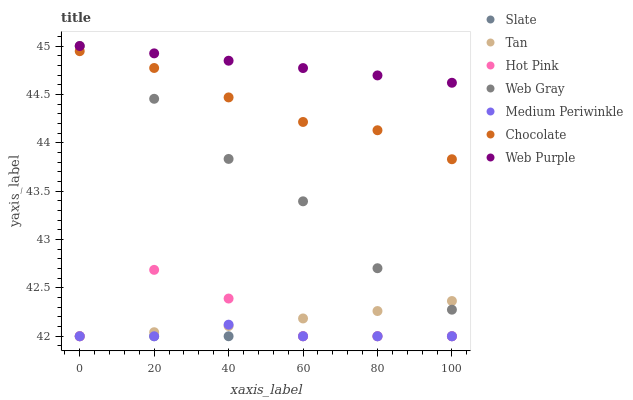Does Slate have the minimum area under the curve?
Answer yes or no. Yes. Does Web Purple have the maximum area under the curve?
Answer yes or no. Yes. Does Hot Pink have the minimum area under the curve?
Answer yes or no. No. Does Hot Pink have the maximum area under the curve?
Answer yes or no. No. Is Slate the smoothest?
Answer yes or no. Yes. Is Hot Pink the roughest?
Answer yes or no. Yes. Is Hot Pink the smoothest?
Answer yes or no. No. Is Slate the roughest?
Answer yes or no. No. Does Slate have the lowest value?
Answer yes or no. Yes. Does Chocolate have the lowest value?
Answer yes or no. No. Does Web Purple have the highest value?
Answer yes or no. Yes. Does Hot Pink have the highest value?
Answer yes or no. No. Is Slate less than Chocolate?
Answer yes or no. Yes. Is Web Purple greater than Slate?
Answer yes or no. Yes. Does Slate intersect Tan?
Answer yes or no. Yes. Is Slate less than Tan?
Answer yes or no. No. Is Slate greater than Tan?
Answer yes or no. No. Does Slate intersect Chocolate?
Answer yes or no. No. 